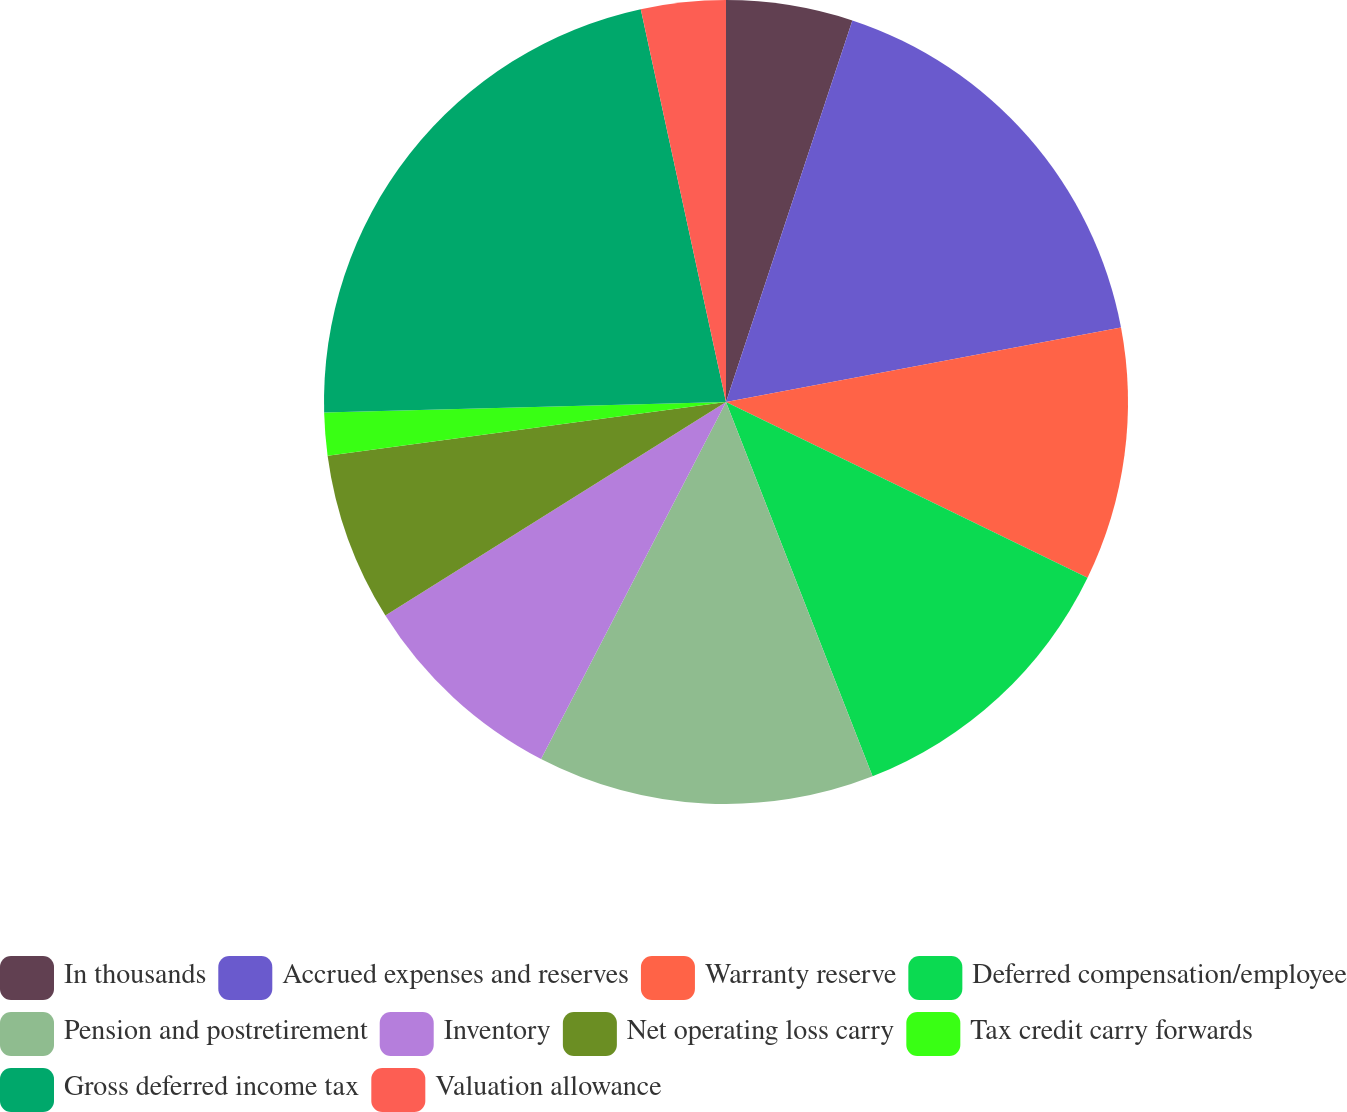<chart> <loc_0><loc_0><loc_500><loc_500><pie_chart><fcel>In thousands<fcel>Accrued expenses and reserves<fcel>Warranty reserve<fcel>Deferred compensation/employee<fcel>Pension and postretirement<fcel>Inventory<fcel>Net operating loss carry<fcel>Tax credit carry forwards<fcel>Gross deferred income tax<fcel>Valuation allowance<nl><fcel>5.09%<fcel>16.94%<fcel>10.17%<fcel>11.86%<fcel>13.55%<fcel>8.48%<fcel>6.78%<fcel>1.71%<fcel>22.02%<fcel>3.4%<nl></chart> 